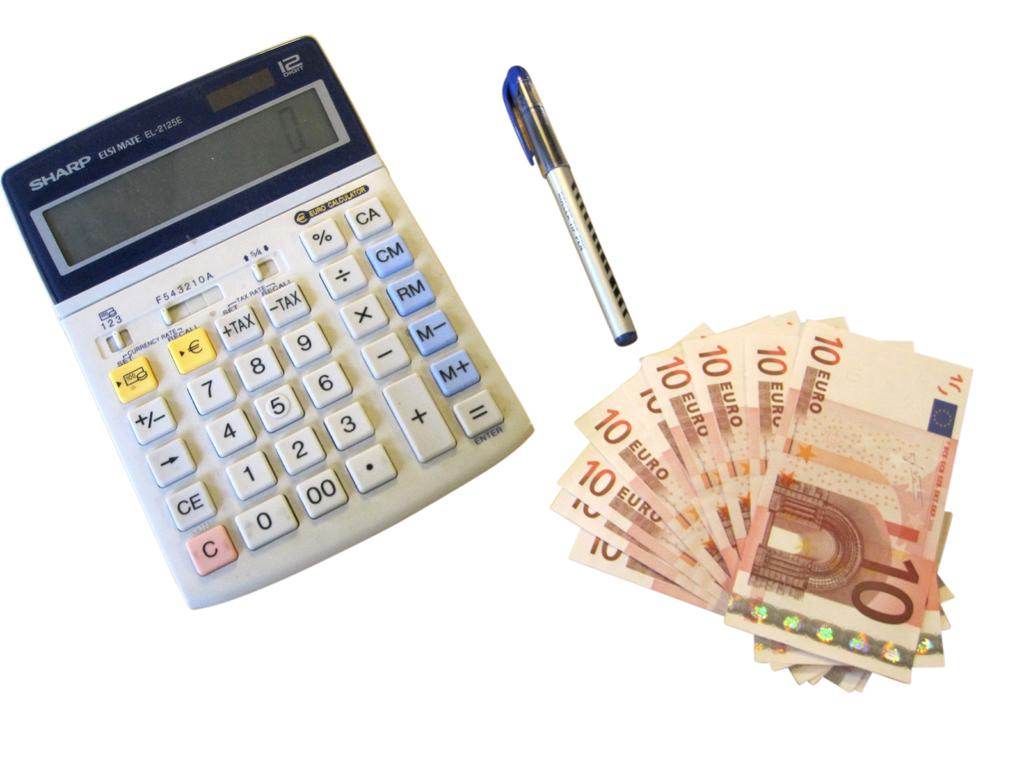What is present in the image that is related to finance or accounting? There is money, a pen, and a calculator in the image. What can be used to write or make marks in the image? There is a pen in the image. What device is present in the image that can perform mathematical calculations? There is a calculator in the image. What features does the calculator have? The calculator has buttons and a screen. How many tomatoes are visible in the image? There are no tomatoes present in the image. What type of house is shown in the background of the image? There is no house visible in the image. 